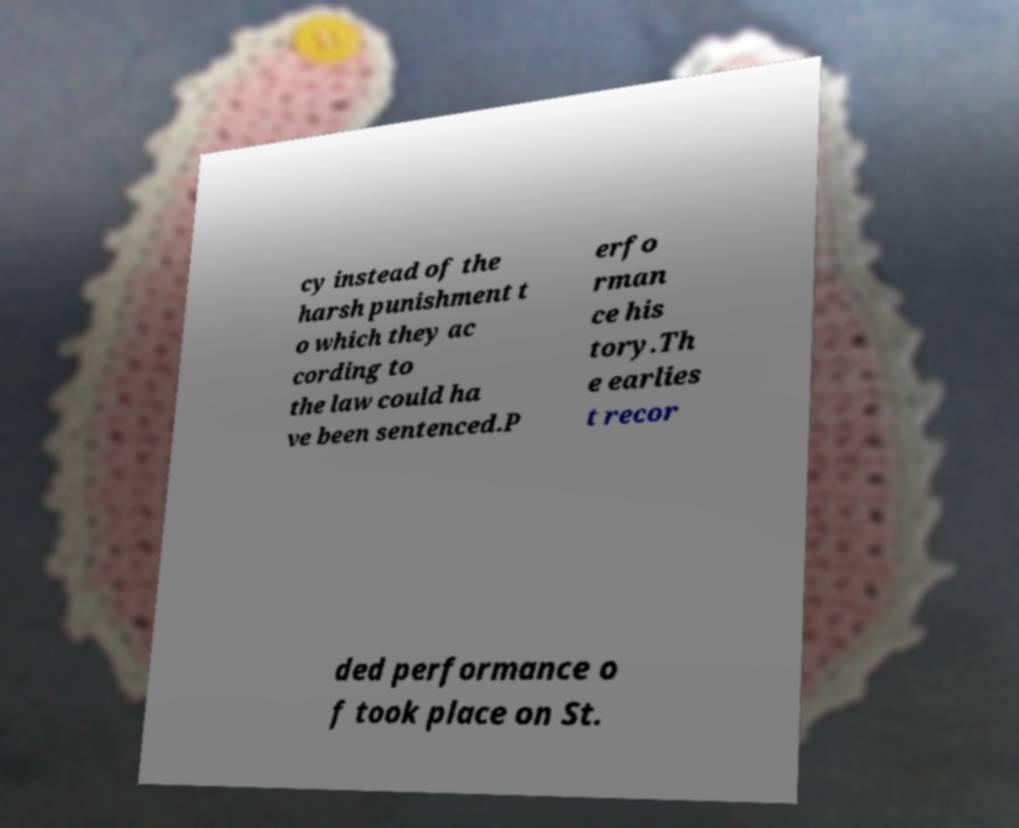For documentation purposes, I need the text within this image transcribed. Could you provide that? cy instead of the harsh punishment t o which they ac cording to the law could ha ve been sentenced.P erfo rman ce his tory.Th e earlies t recor ded performance o f took place on St. 